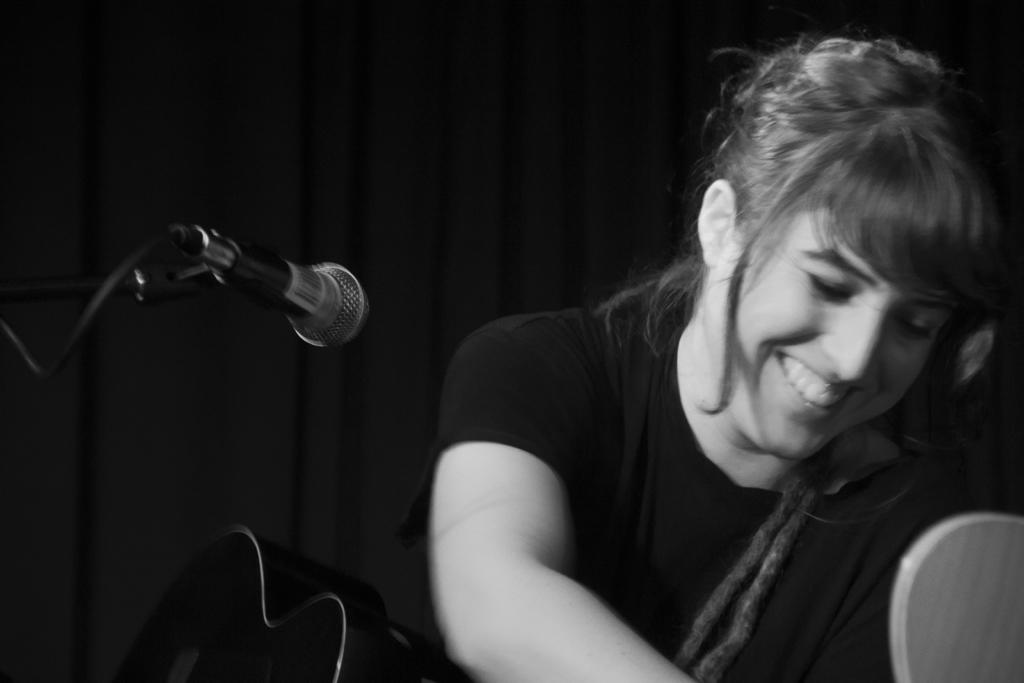Who is the main subject in the image? There is a girl in the image. Where is the girl located in the image? The girl is at the center of the image. What is the girl's expression in the image? The girl is smiling in the image. What is the girl holding in the image? The girl is holding a musical instrument in the image. What object is visible in the front of the image? There is a microphone in the front of the image. What type of kitten is the girl exchanging with the expert in the image? There is no kitten or expert present in the image. 